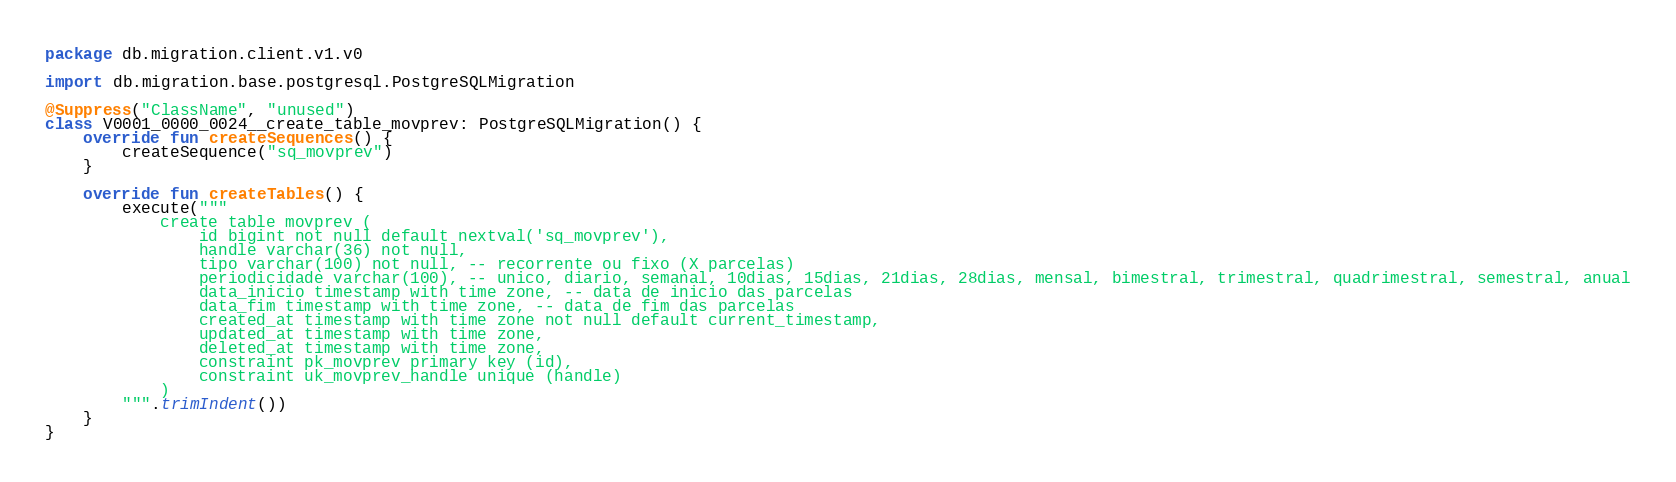Convert code to text. <code><loc_0><loc_0><loc_500><loc_500><_Kotlin_>package db.migration.client.v1.v0

import db.migration.base.postgresql.PostgreSQLMigration

@Suppress("ClassName", "unused")
class V0001_0000_0024__create_table_movprev: PostgreSQLMigration() {
    override fun createSequences() {
        createSequence("sq_movprev")
    }

    override fun createTables() {
        execute("""
            create table movprev (
                id bigint not null default nextval('sq_movprev'),
                handle varchar(36) not null,
                tipo varchar(100) not null, -- recorrente ou fixo (X parcelas)
                periodicidade varchar(100), -- unico, diario, semanal, 10dias, 15dias, 21dias, 28dias, mensal, bimestral, trimestral, quadrimestral, semestral, anual
                data_inicio timestamp with time zone, -- data de inicio das parcelas
                data_fim timestamp with time zone, -- data de fim das parcelas
                created_at timestamp with time zone not null default current_timestamp,
                updated_at timestamp with time zone,
                deleted_at timestamp with time zone,
                constraint pk_movprev primary key (id),
                constraint uk_movprev_handle unique (handle)
            )
        """.trimIndent())
    }
}</code> 